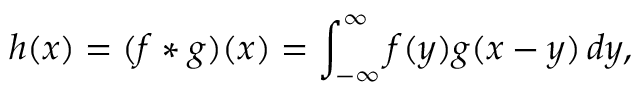Convert formula to latex. <formula><loc_0><loc_0><loc_500><loc_500>h ( x ) = ( f * g ) ( x ) = \int _ { - \infty } ^ { \infty } f ( y ) g ( x - y ) \, d y ,</formula> 